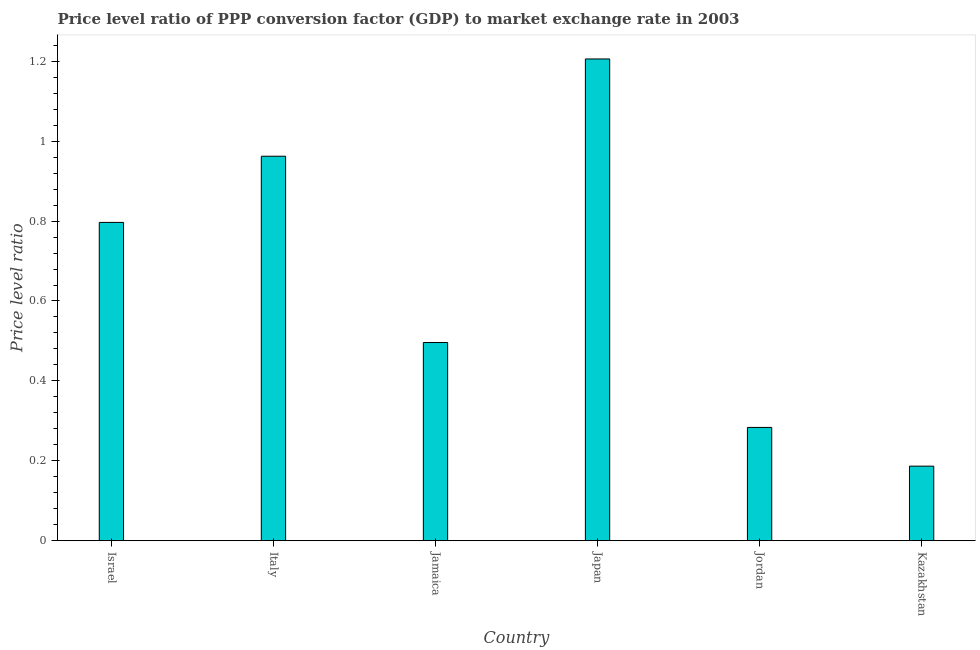Does the graph contain any zero values?
Provide a succinct answer. No. Does the graph contain grids?
Keep it short and to the point. No. What is the title of the graph?
Your answer should be compact. Price level ratio of PPP conversion factor (GDP) to market exchange rate in 2003. What is the label or title of the X-axis?
Give a very brief answer. Country. What is the label or title of the Y-axis?
Offer a very short reply. Price level ratio. What is the price level ratio in Kazakhstan?
Your answer should be compact. 0.19. Across all countries, what is the maximum price level ratio?
Make the answer very short. 1.21. Across all countries, what is the minimum price level ratio?
Keep it short and to the point. 0.19. In which country was the price level ratio minimum?
Offer a terse response. Kazakhstan. What is the sum of the price level ratio?
Your response must be concise. 3.93. What is the difference between the price level ratio in Israel and Jordan?
Give a very brief answer. 0.51. What is the average price level ratio per country?
Make the answer very short. 0.66. What is the median price level ratio?
Provide a succinct answer. 0.65. What is the ratio of the price level ratio in Italy to that in Japan?
Keep it short and to the point. 0.8. Is the price level ratio in Japan less than that in Jordan?
Provide a succinct answer. No. What is the difference between the highest and the second highest price level ratio?
Offer a very short reply. 0.24. What is the difference between the highest and the lowest price level ratio?
Provide a short and direct response. 1.02. In how many countries, is the price level ratio greater than the average price level ratio taken over all countries?
Ensure brevity in your answer.  3. How many countries are there in the graph?
Provide a short and direct response. 6. What is the Price level ratio in Israel?
Provide a succinct answer. 0.8. What is the Price level ratio in Italy?
Offer a terse response. 0.96. What is the Price level ratio in Jamaica?
Your answer should be very brief. 0.5. What is the Price level ratio of Japan?
Ensure brevity in your answer.  1.21. What is the Price level ratio of Jordan?
Give a very brief answer. 0.28. What is the Price level ratio of Kazakhstan?
Offer a very short reply. 0.19. What is the difference between the Price level ratio in Israel and Italy?
Your answer should be compact. -0.17. What is the difference between the Price level ratio in Israel and Jamaica?
Ensure brevity in your answer.  0.3. What is the difference between the Price level ratio in Israel and Japan?
Your answer should be compact. -0.41. What is the difference between the Price level ratio in Israel and Jordan?
Your answer should be very brief. 0.51. What is the difference between the Price level ratio in Israel and Kazakhstan?
Provide a short and direct response. 0.61. What is the difference between the Price level ratio in Italy and Jamaica?
Provide a succinct answer. 0.47. What is the difference between the Price level ratio in Italy and Japan?
Make the answer very short. -0.24. What is the difference between the Price level ratio in Italy and Jordan?
Give a very brief answer. 0.68. What is the difference between the Price level ratio in Italy and Kazakhstan?
Give a very brief answer. 0.78. What is the difference between the Price level ratio in Jamaica and Japan?
Offer a very short reply. -0.71. What is the difference between the Price level ratio in Jamaica and Jordan?
Give a very brief answer. 0.21. What is the difference between the Price level ratio in Jamaica and Kazakhstan?
Your answer should be compact. 0.31. What is the difference between the Price level ratio in Japan and Jordan?
Make the answer very short. 0.92. What is the difference between the Price level ratio in Japan and Kazakhstan?
Provide a succinct answer. 1.02. What is the difference between the Price level ratio in Jordan and Kazakhstan?
Provide a short and direct response. 0.1. What is the ratio of the Price level ratio in Israel to that in Italy?
Give a very brief answer. 0.83. What is the ratio of the Price level ratio in Israel to that in Jamaica?
Ensure brevity in your answer.  1.61. What is the ratio of the Price level ratio in Israel to that in Japan?
Offer a terse response. 0.66. What is the ratio of the Price level ratio in Israel to that in Jordan?
Offer a terse response. 2.81. What is the ratio of the Price level ratio in Israel to that in Kazakhstan?
Provide a succinct answer. 4.27. What is the ratio of the Price level ratio in Italy to that in Jamaica?
Your answer should be very brief. 1.94. What is the ratio of the Price level ratio in Italy to that in Japan?
Give a very brief answer. 0.8. What is the ratio of the Price level ratio in Italy to that in Jordan?
Provide a short and direct response. 3.39. What is the ratio of the Price level ratio in Italy to that in Kazakhstan?
Offer a very short reply. 5.16. What is the ratio of the Price level ratio in Jamaica to that in Japan?
Your response must be concise. 0.41. What is the ratio of the Price level ratio in Jamaica to that in Jordan?
Offer a very short reply. 1.75. What is the ratio of the Price level ratio in Jamaica to that in Kazakhstan?
Ensure brevity in your answer.  2.66. What is the ratio of the Price level ratio in Japan to that in Jordan?
Your response must be concise. 4.25. What is the ratio of the Price level ratio in Japan to that in Kazakhstan?
Offer a terse response. 6.46. What is the ratio of the Price level ratio in Jordan to that in Kazakhstan?
Your answer should be compact. 1.52. 